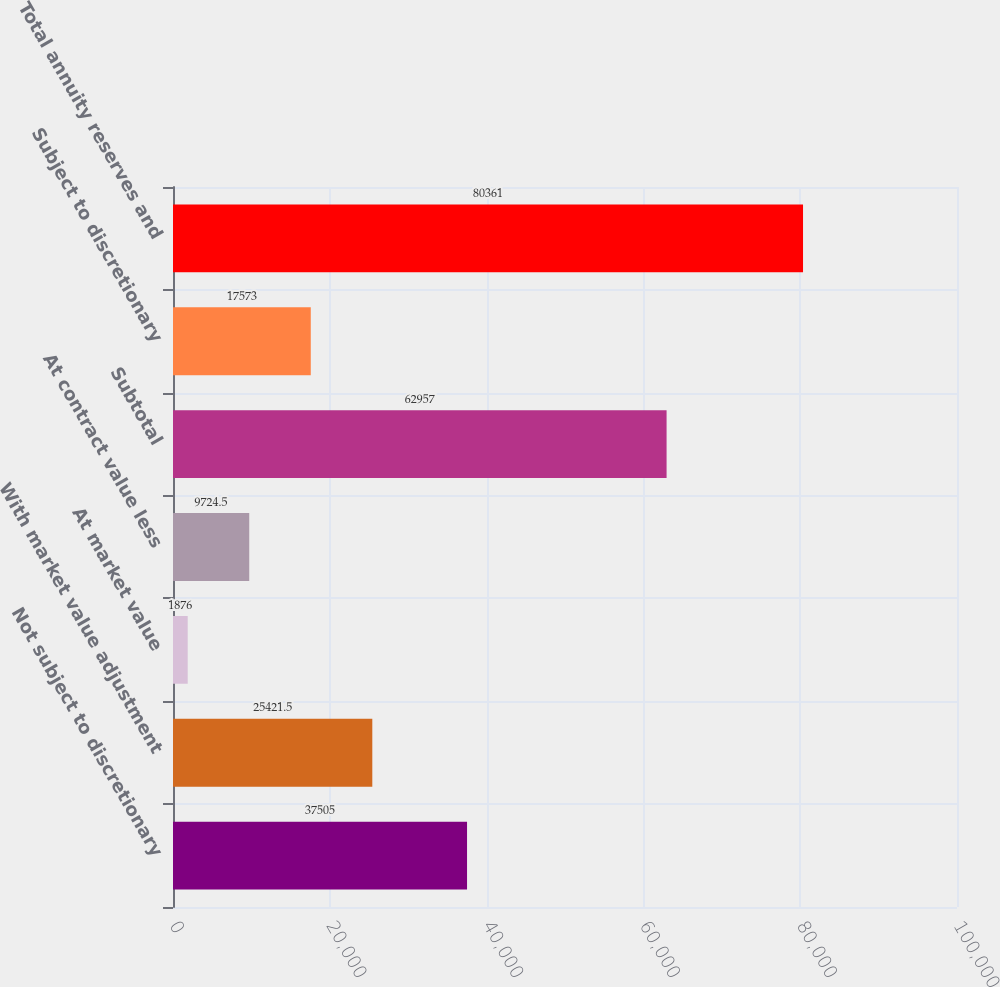<chart> <loc_0><loc_0><loc_500><loc_500><bar_chart><fcel>Not subject to discretionary<fcel>With market value adjustment<fcel>At market value<fcel>At contract value less<fcel>Subtotal<fcel>Subject to discretionary<fcel>Total annuity reserves and<nl><fcel>37505<fcel>25421.5<fcel>1876<fcel>9724.5<fcel>62957<fcel>17573<fcel>80361<nl></chart> 